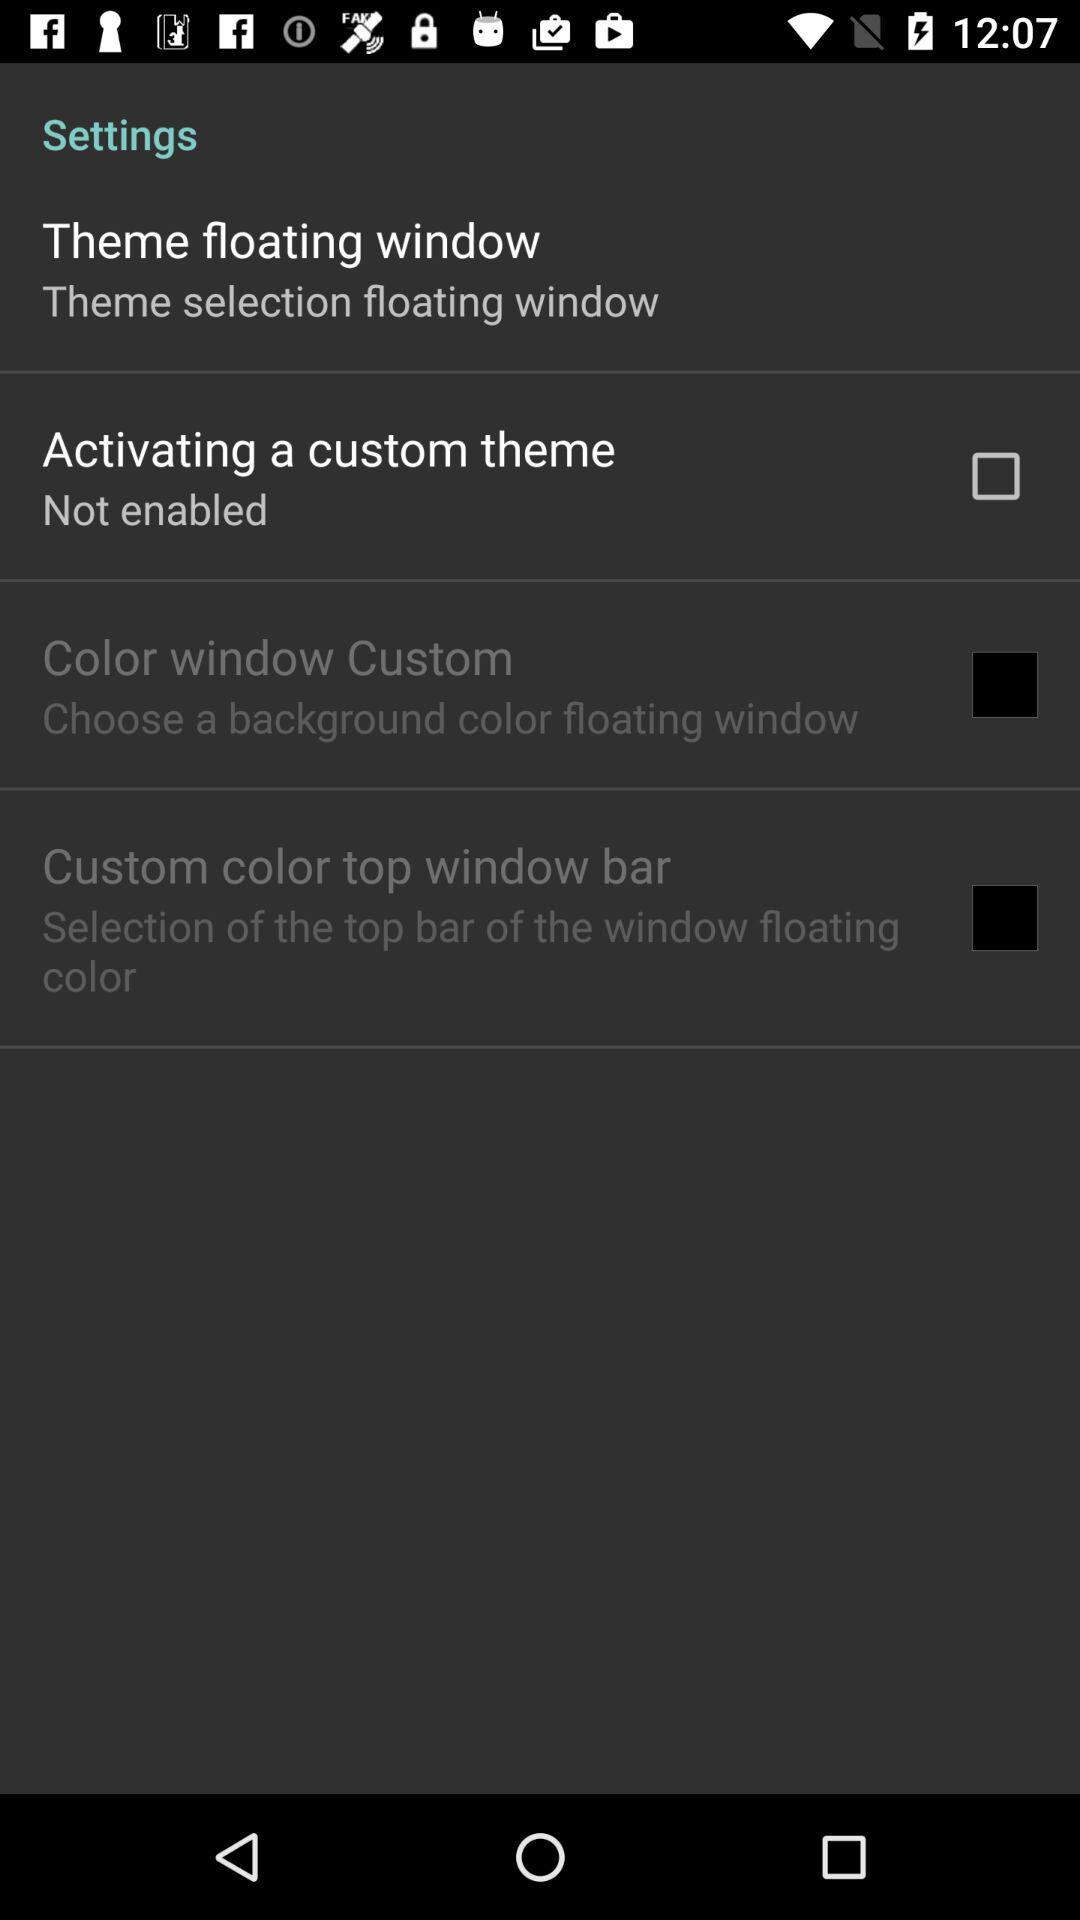How many items are in the settings menu?
Answer the question using a single word or phrase. 4 